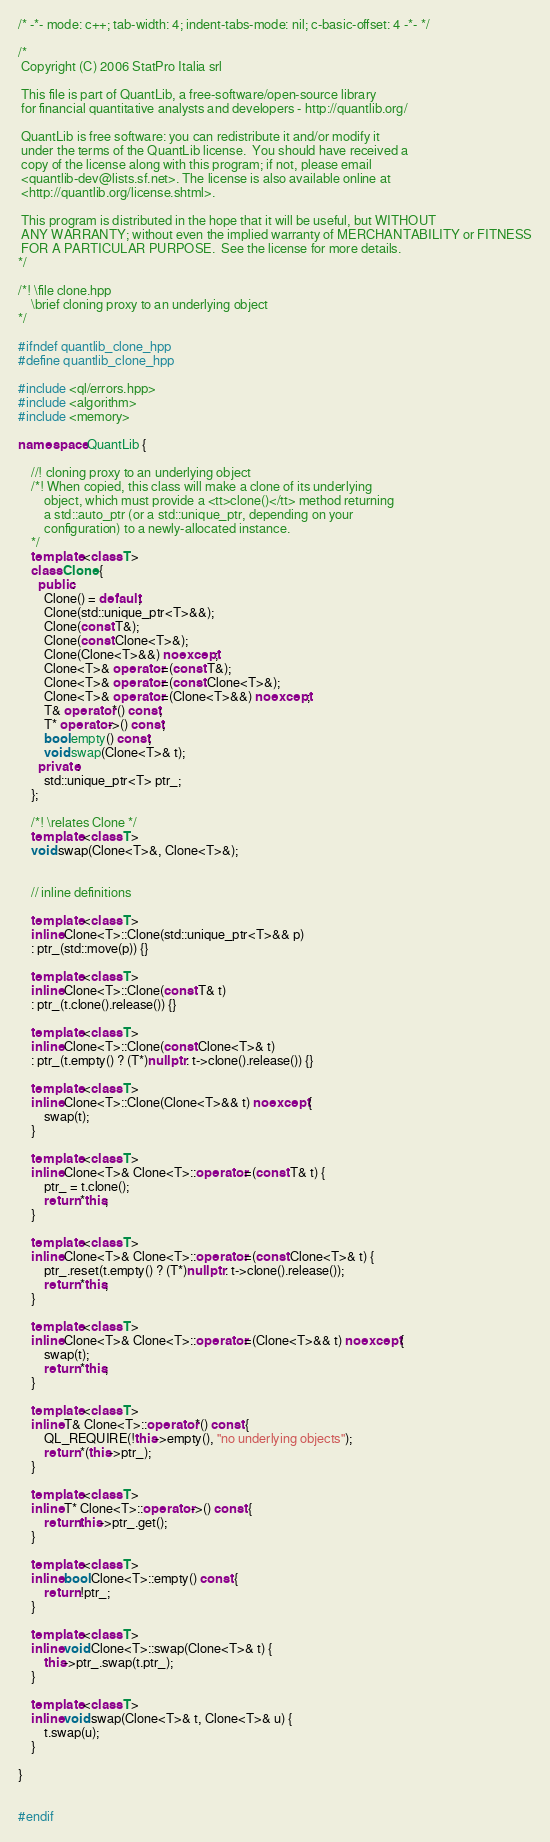Convert code to text. <code><loc_0><loc_0><loc_500><loc_500><_C++_>/* -*- mode: c++; tab-width: 4; indent-tabs-mode: nil; c-basic-offset: 4 -*- */

/*
 Copyright (C) 2006 StatPro Italia srl

 This file is part of QuantLib, a free-software/open-source library
 for financial quantitative analysts and developers - http://quantlib.org/

 QuantLib is free software: you can redistribute it and/or modify it
 under the terms of the QuantLib license.  You should have received a
 copy of the license along with this program; if not, please email
 <quantlib-dev@lists.sf.net>. The license is also available online at
 <http://quantlib.org/license.shtml>.

 This program is distributed in the hope that it will be useful, but WITHOUT
 ANY WARRANTY; without even the implied warranty of MERCHANTABILITY or FITNESS
 FOR A PARTICULAR PURPOSE.  See the license for more details.
*/

/*! \file clone.hpp
    \brief cloning proxy to an underlying object
*/

#ifndef quantlib_clone_hpp
#define quantlib_clone_hpp

#include <ql/errors.hpp>
#include <algorithm>
#include <memory>

namespace QuantLib {

    //! cloning proxy to an underlying object
    /*! When copied, this class will make a clone of its underlying
        object, which must provide a <tt>clone()</tt> method returning
        a std::auto_ptr (or a std::unique_ptr, depending on your
        configuration) to a newly-allocated instance.
    */
    template <class T>
    class Clone {
      public:
        Clone() = default;
        Clone(std::unique_ptr<T>&&);
        Clone(const T&);
        Clone(const Clone<T>&);
        Clone(Clone<T>&&) noexcept;
        Clone<T>& operator=(const T&);
        Clone<T>& operator=(const Clone<T>&);
        Clone<T>& operator=(Clone<T>&&) noexcept;
        T& operator*() const;
        T* operator->() const;
        bool empty() const;
        void swap(Clone<T>& t);
      private:
        std::unique_ptr<T> ptr_;
    };

    /*! \relates Clone */
    template <class T>
    void swap(Clone<T>&, Clone<T>&);


    // inline definitions

    template <class T>
    inline Clone<T>::Clone(std::unique_ptr<T>&& p)
    : ptr_(std::move(p)) {}

    template <class T>
    inline Clone<T>::Clone(const T& t)
    : ptr_(t.clone().release()) {}

    template <class T>
    inline Clone<T>::Clone(const Clone<T>& t)
    : ptr_(t.empty() ? (T*)nullptr : t->clone().release()) {}

    template <class T>
    inline Clone<T>::Clone(Clone<T>&& t) noexcept {
        swap(t);
    }

    template <class T>
    inline Clone<T>& Clone<T>::operator=(const T& t) {
        ptr_ = t.clone();
        return *this;
    }

    template <class T>
    inline Clone<T>& Clone<T>::operator=(const Clone<T>& t) {
        ptr_.reset(t.empty() ? (T*)nullptr : t->clone().release());
        return *this;
    }

    template <class T>
    inline Clone<T>& Clone<T>::operator=(Clone<T>&& t) noexcept {
        swap(t);
        return *this;
    }

    template <class T>
    inline T& Clone<T>::operator*() const {
        QL_REQUIRE(!this->empty(), "no underlying objects");
        return *(this->ptr_);
    }

    template <class T>
    inline T* Clone<T>::operator->() const {
        return this->ptr_.get();
    }

    template <class T>
    inline bool Clone<T>::empty() const {
        return !ptr_;
    }

    template <class T>
    inline void Clone<T>::swap(Clone<T>& t) {
        this->ptr_.swap(t.ptr_);
    }

    template <class T>
    inline void swap(Clone<T>& t, Clone<T>& u) {
        t.swap(u);
    }

}


#endif
</code> 